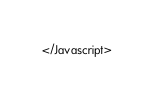<code> <loc_0><loc_0><loc_500><loc_500><_XML_></Javascript>
</code> 